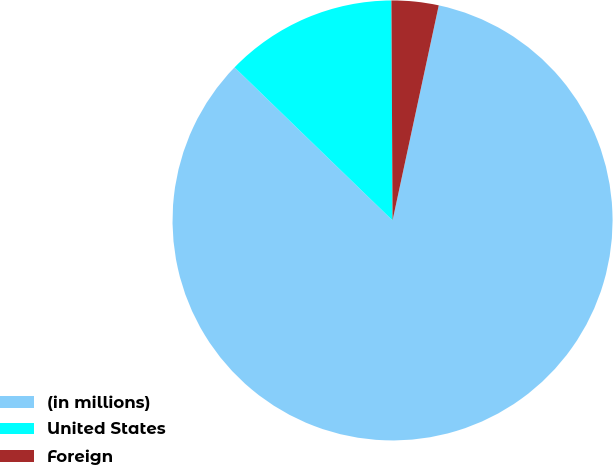Convert chart to OTSL. <chart><loc_0><loc_0><loc_500><loc_500><pie_chart><fcel>(in millions)<fcel>United States<fcel>Foreign<nl><fcel>83.88%<fcel>12.67%<fcel>3.45%<nl></chart> 